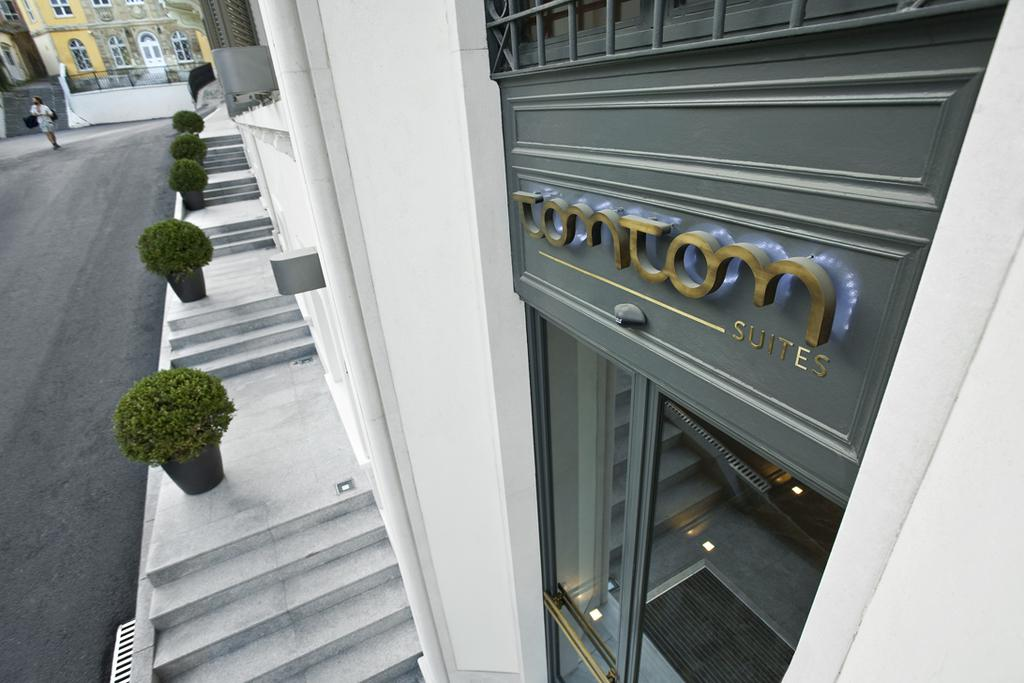<image>
Share a concise interpretation of the image provided. The area in front of tomtom suites has many stairways and bushes. 